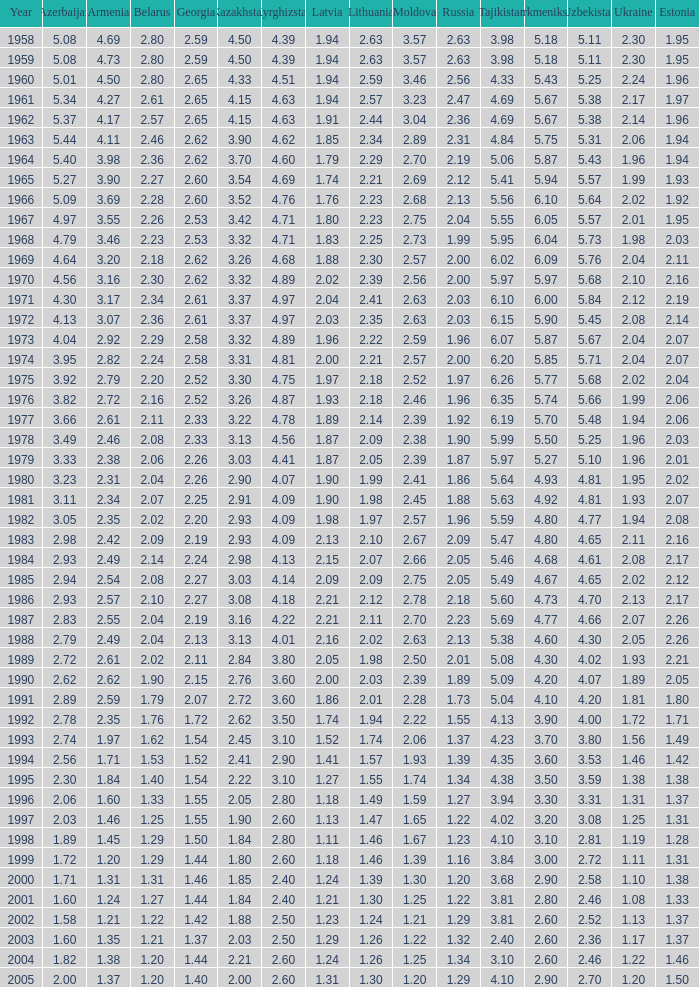What is the smallest value for kazakhstan, considering kyrgyzstan at 4.62 and belarus below 2.46? None. 